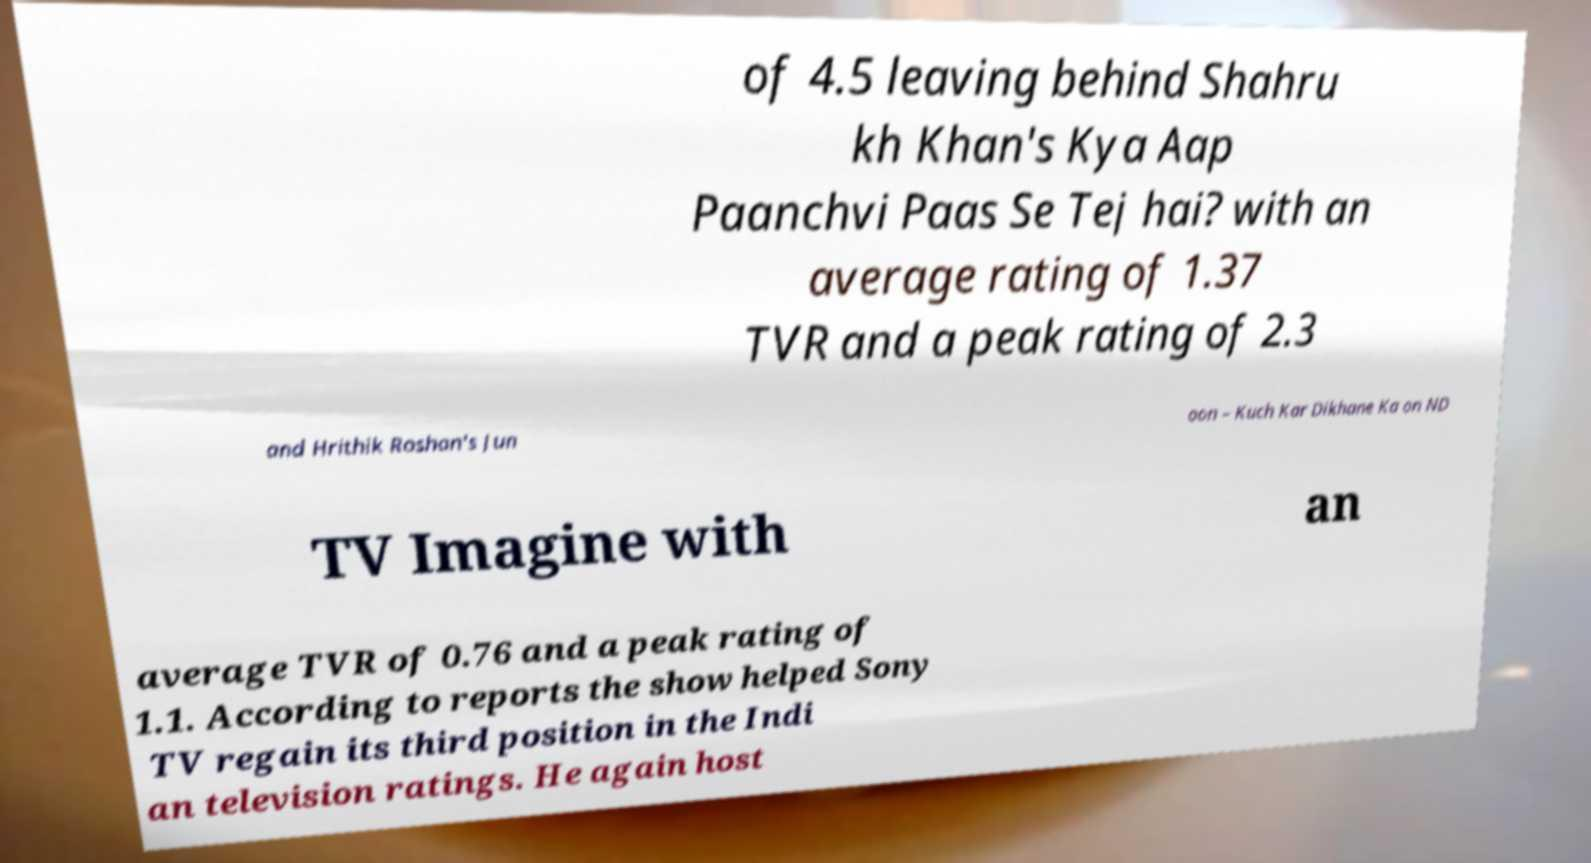Please identify and transcribe the text found in this image. of 4.5 leaving behind Shahru kh Khan's Kya Aap Paanchvi Paas Se Tej hai? with an average rating of 1.37 TVR and a peak rating of 2.3 and Hrithik Roshan's Jun oon – Kuch Kar Dikhane Ka on ND TV Imagine with an average TVR of 0.76 and a peak rating of 1.1. According to reports the show helped Sony TV regain its third position in the Indi an television ratings. He again host 